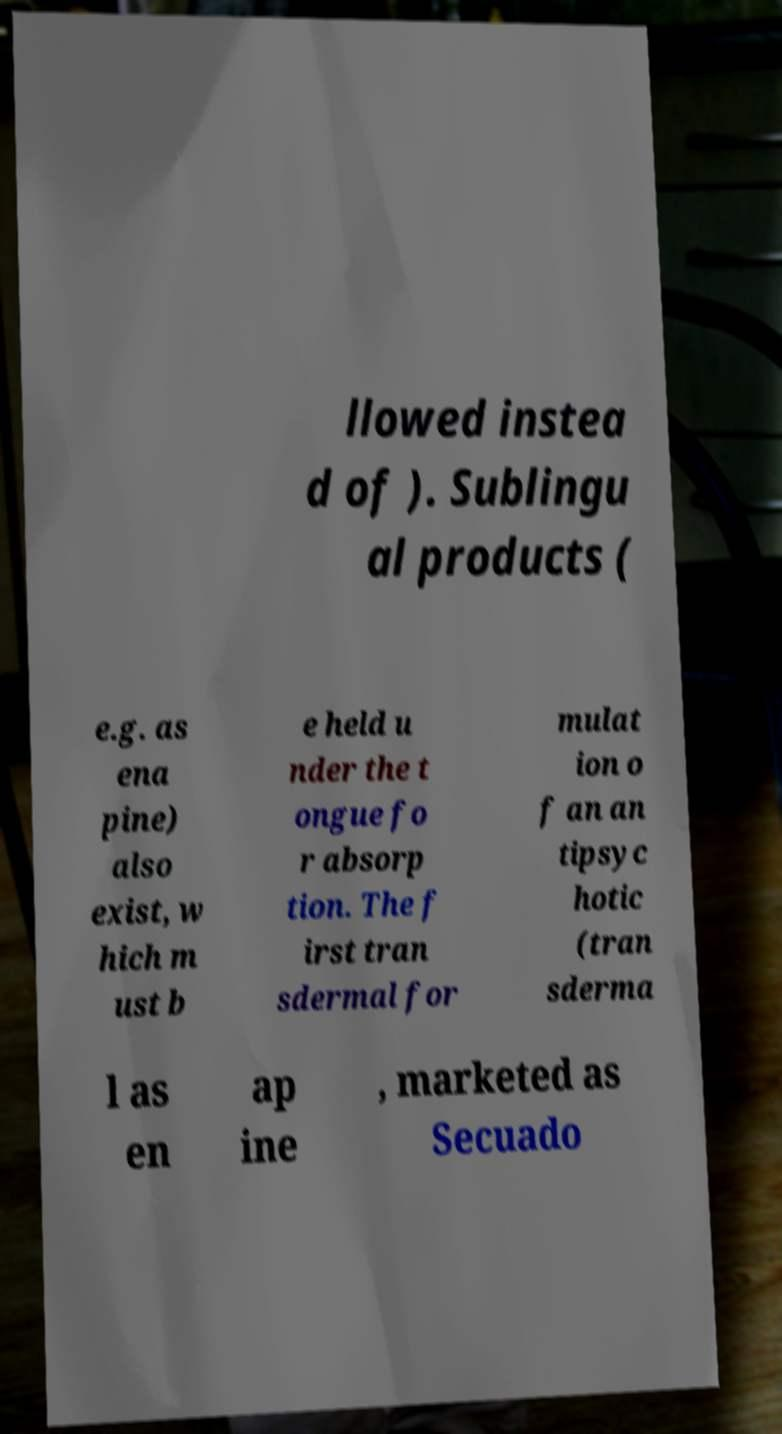I need the written content from this picture converted into text. Can you do that? llowed instea d of ). Sublingu al products ( e.g. as ena pine) also exist, w hich m ust b e held u nder the t ongue fo r absorp tion. The f irst tran sdermal for mulat ion o f an an tipsyc hotic (tran sderma l as en ap ine , marketed as Secuado 